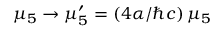<formula> <loc_0><loc_0><loc_500><loc_500>\mu _ { 5 } \to \mu _ { 5 } ^ { \prime } = ( 4 \alpha / \hbar { c } ) \, \mu _ { 5 }</formula> 